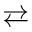<formula> <loc_0><loc_0><loc_500><loc_500>\right l e f t a r r o w s</formula> 